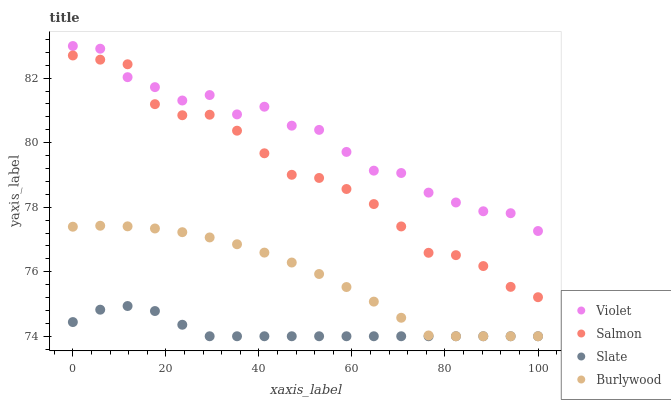Does Slate have the minimum area under the curve?
Answer yes or no. Yes. Does Violet have the maximum area under the curve?
Answer yes or no. Yes. Does Salmon have the minimum area under the curve?
Answer yes or no. No. Does Salmon have the maximum area under the curve?
Answer yes or no. No. Is Burlywood the smoothest?
Answer yes or no. Yes. Is Violet the roughest?
Answer yes or no. Yes. Is Slate the smoothest?
Answer yes or no. No. Is Slate the roughest?
Answer yes or no. No. Does Burlywood have the lowest value?
Answer yes or no. Yes. Does Salmon have the lowest value?
Answer yes or no. No. Does Violet have the highest value?
Answer yes or no. Yes. Does Salmon have the highest value?
Answer yes or no. No. Is Slate less than Salmon?
Answer yes or no. Yes. Is Salmon greater than Burlywood?
Answer yes or no. Yes. Does Burlywood intersect Slate?
Answer yes or no. Yes. Is Burlywood less than Slate?
Answer yes or no. No. Is Burlywood greater than Slate?
Answer yes or no. No. Does Slate intersect Salmon?
Answer yes or no. No. 